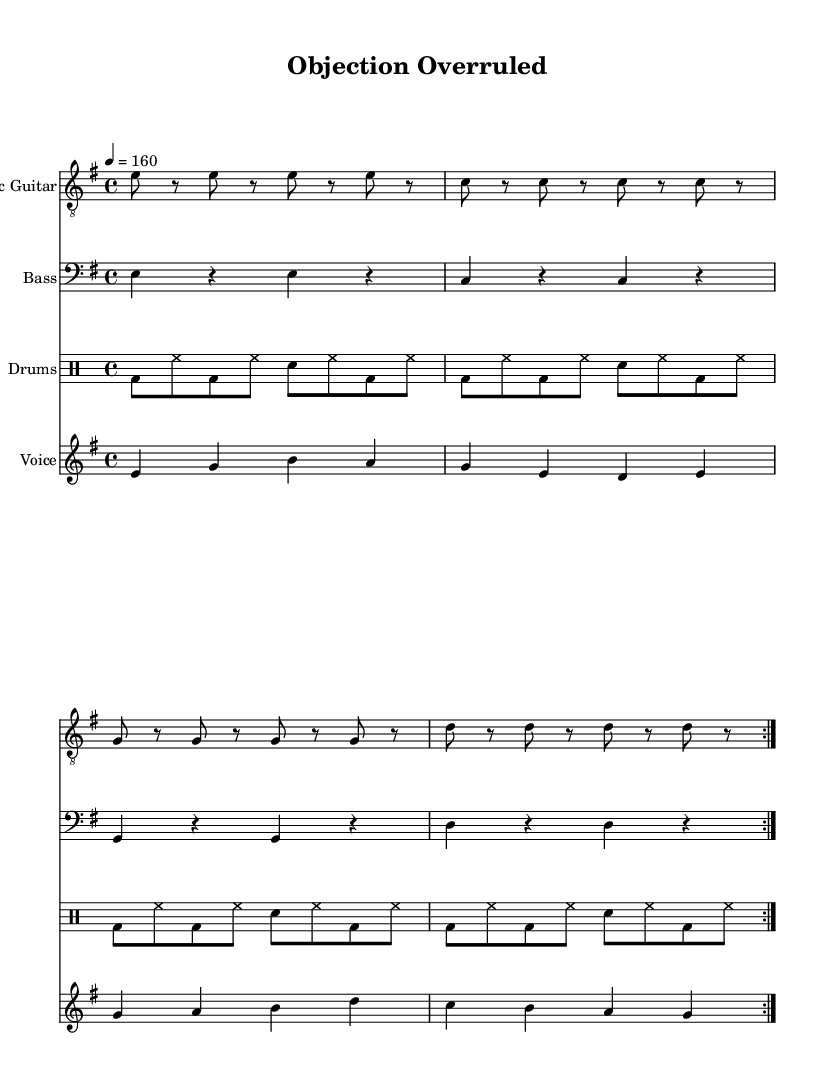What is the key signature of this music? The key signature is indicated at the beginning of the staff and shows that there are no sharps or flats. The note is E, and the minor designation tells us it is E minor.
Answer: E minor What is the time signature of the music? The time signature is found at the beginning of the staff, and it indicates how many beats are in each measure. Here, it shows a four-four time signature, meaning four beats per measure.
Answer: 4/4 What is the tempo of the piece? The tempo marking shows the speed at which the music should be played. In this piece, the indication states "4 = 160," which means there are 160 beats per minute.
Answer: 160 How many times is the main guitar riff repeated? The repeat indication "volta 2" in the guitar part means that the main riff is played twice in total before moving on to the next section.
Answer: 2 What is the primary theme of the lyrics? The lyrics focus on legal jargon and the mockery of the formalities often associated with the legal profession, specifically using the phrase "Objection Overruled" as a satirical remark.
Answer: Mocking legal formality What instruments are featured in this piece? By examining the score, you can see four distinct staves, each representing a different instrument: Electric Guitar, Bass, Drums, and Voice. This indicates a standard punk setup with guitar, bass, drums, and vocals.
Answer: Electric Guitar, Bass, Drums, Voice What aspect of punk music is reflected in this sheet music? The song's fast tempo, heavy use of power chords in the guitar, and direct and mocking lyrics portray a rebellious attitude, characteristic of punk music, particularly against formal structures like those of the legal profession.
Answer: Rebellious attitude 